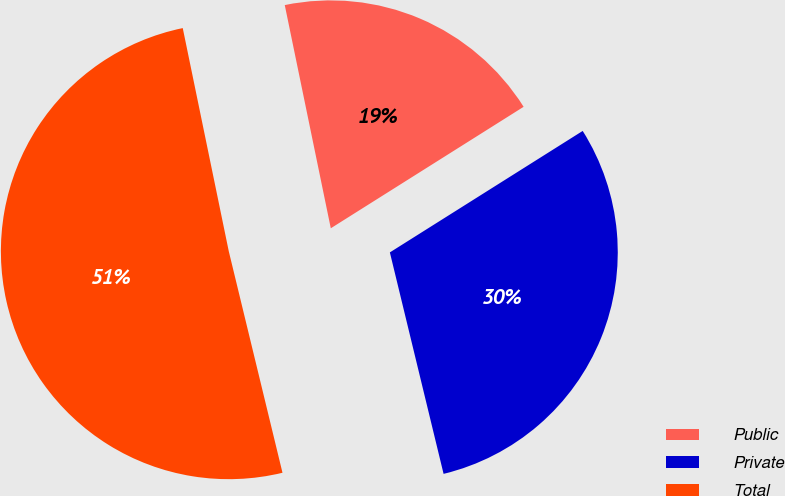Convert chart to OTSL. <chart><loc_0><loc_0><loc_500><loc_500><pie_chart><fcel>Public<fcel>Private<fcel>Total<nl><fcel>19.29%<fcel>30.16%<fcel>50.55%<nl></chart> 